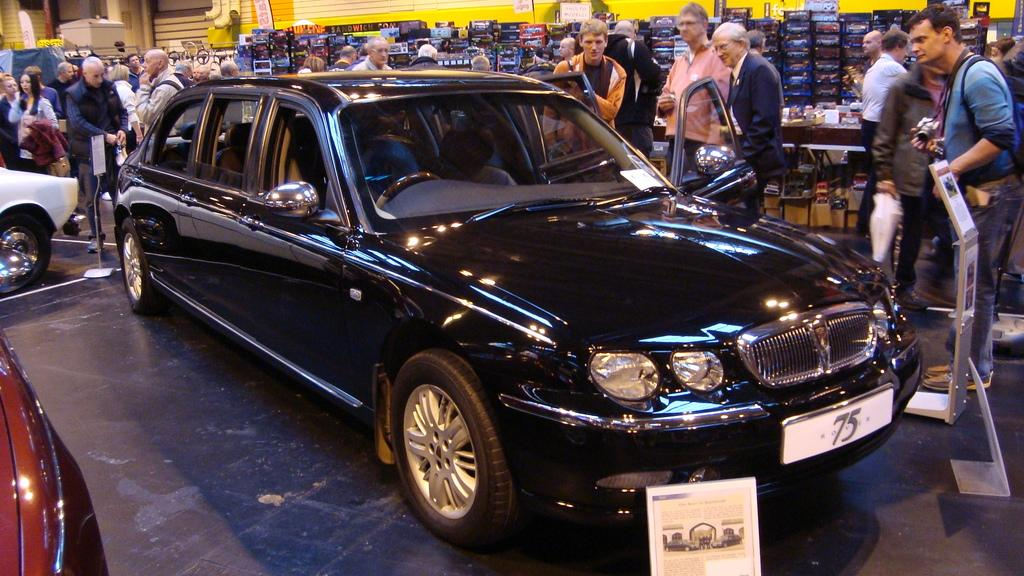How many cars are present in the image? There are two cars in the image. What else can be seen in the image besides the cars? There are men standing behind the cars. Can you describe the background of the image? There are objects visible in the background of the image. What type of respect can be seen in the image? There is no indication of respect in the image; it simply shows two cars and men standing behind them. 